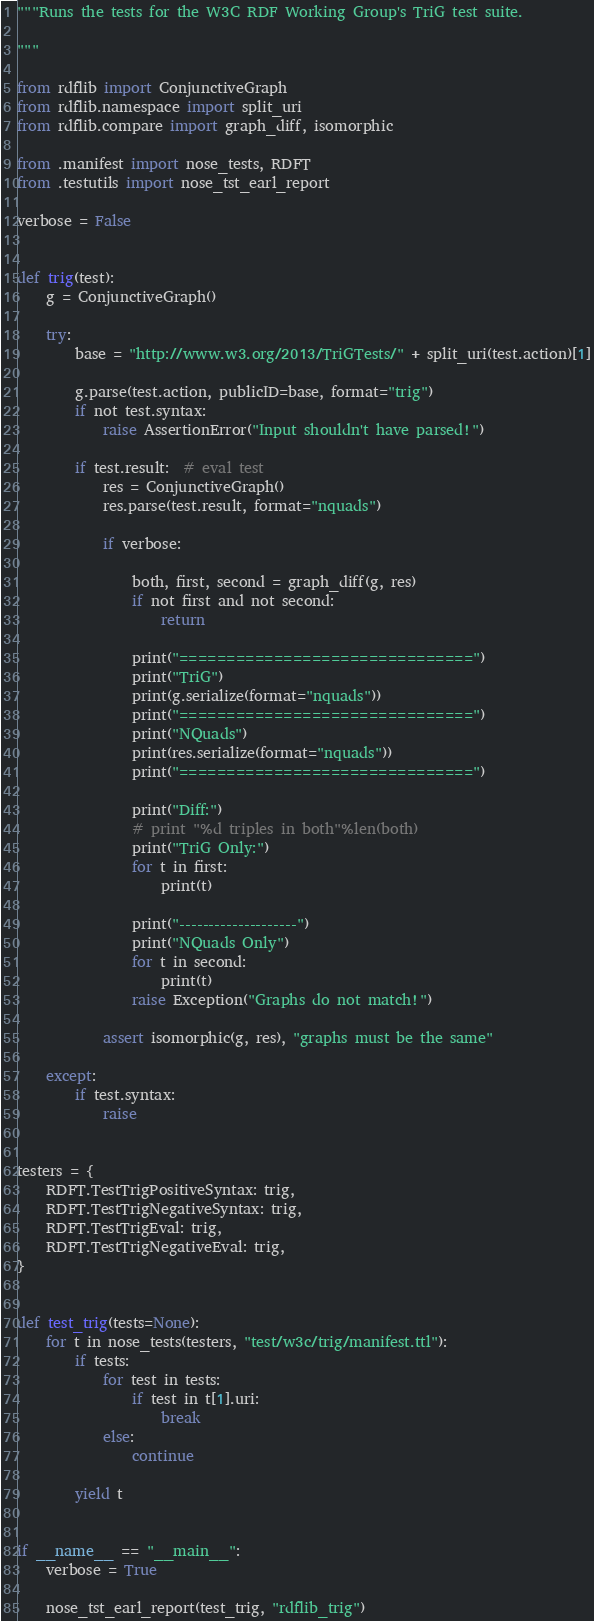<code> <loc_0><loc_0><loc_500><loc_500><_Python_>"""Runs the tests for the W3C RDF Working Group's TriG test suite.

"""

from rdflib import ConjunctiveGraph
from rdflib.namespace import split_uri
from rdflib.compare import graph_diff, isomorphic

from .manifest import nose_tests, RDFT
from .testutils import nose_tst_earl_report

verbose = False


def trig(test):
    g = ConjunctiveGraph()

    try:
        base = "http://www.w3.org/2013/TriGTests/" + split_uri(test.action)[1]

        g.parse(test.action, publicID=base, format="trig")
        if not test.syntax:
            raise AssertionError("Input shouldn't have parsed!")

        if test.result:  # eval test
            res = ConjunctiveGraph()
            res.parse(test.result, format="nquads")

            if verbose:

                both, first, second = graph_diff(g, res)
                if not first and not second:
                    return

                print("===============================")
                print("TriG")
                print(g.serialize(format="nquads"))
                print("===============================")
                print("NQuads")
                print(res.serialize(format="nquads"))
                print("===============================")

                print("Diff:")
                # print "%d triples in both"%len(both)
                print("TriG Only:")
                for t in first:
                    print(t)

                print("--------------------")
                print("NQuads Only")
                for t in second:
                    print(t)
                raise Exception("Graphs do not match!")

            assert isomorphic(g, res), "graphs must be the same"

    except:
        if test.syntax:
            raise


testers = {
    RDFT.TestTrigPositiveSyntax: trig,
    RDFT.TestTrigNegativeSyntax: trig,
    RDFT.TestTrigEval: trig,
    RDFT.TestTrigNegativeEval: trig,
}


def test_trig(tests=None):
    for t in nose_tests(testers, "test/w3c/trig/manifest.ttl"):
        if tests:
            for test in tests:
                if test in t[1].uri:
                    break
            else:
                continue

        yield t


if __name__ == "__main__":
    verbose = True

    nose_tst_earl_report(test_trig, "rdflib_trig")
</code> 